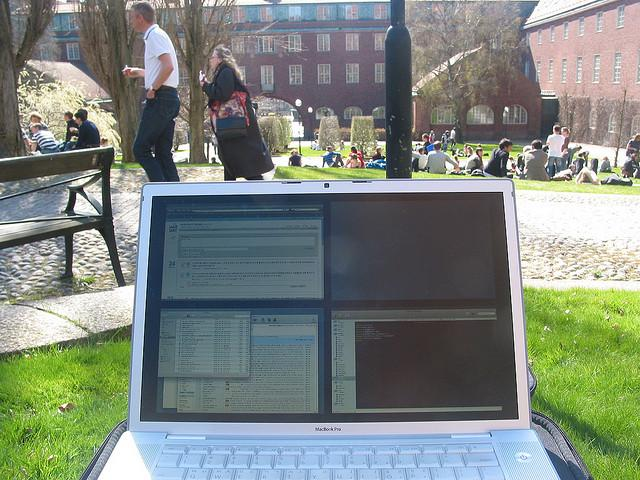Where is this lap top set up? Please explain your reasoning. school. The laptop is for school. 